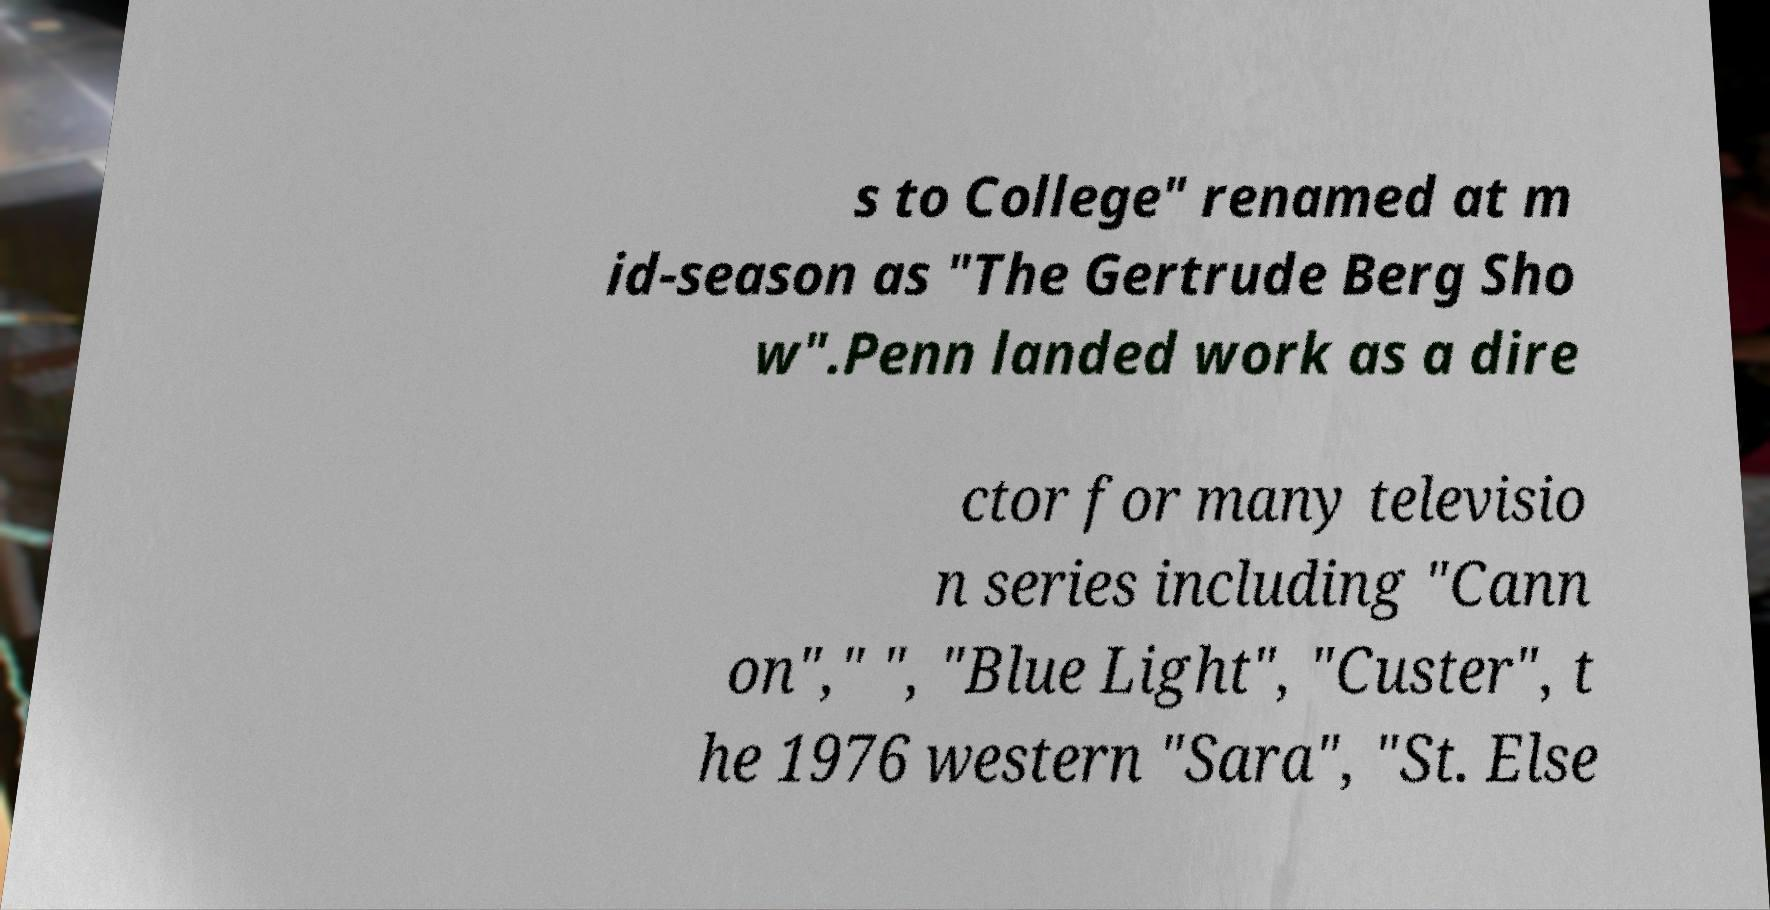What messages or text are displayed in this image? I need them in a readable, typed format. s to College" renamed at m id-season as "The Gertrude Berg Sho w".Penn landed work as a dire ctor for many televisio n series including "Cann on"," ", "Blue Light", "Custer", t he 1976 western "Sara", "St. Else 